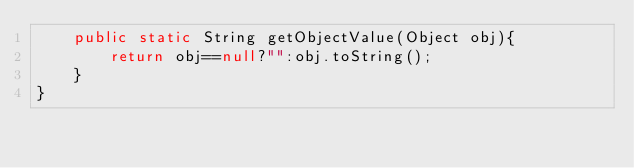Convert code to text. <code><loc_0><loc_0><loc_500><loc_500><_Java_>    public static String getObjectValue(Object obj){
        return obj==null?"":obj.toString();
    }
}
</code> 